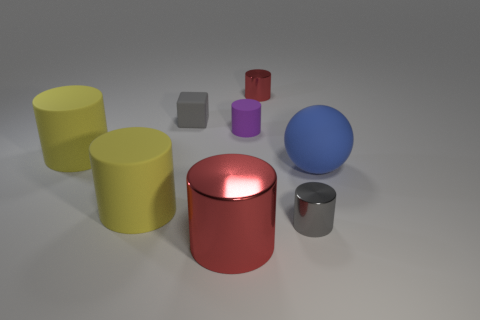Subtract all big red metallic cylinders. How many cylinders are left? 5 Subtract all red cylinders. How many cylinders are left? 4 Add 2 small red matte cubes. How many objects exist? 10 Subtract all blocks. How many objects are left? 7 Subtract all red blocks. How many yellow cylinders are left? 2 Subtract all cyan cubes. Subtract all cyan cylinders. How many cubes are left? 1 Subtract all small brown matte cylinders. Subtract all small gray rubber things. How many objects are left? 7 Add 6 gray things. How many gray things are left? 8 Add 8 big matte spheres. How many big matte spheres exist? 9 Subtract 0 cyan spheres. How many objects are left? 8 